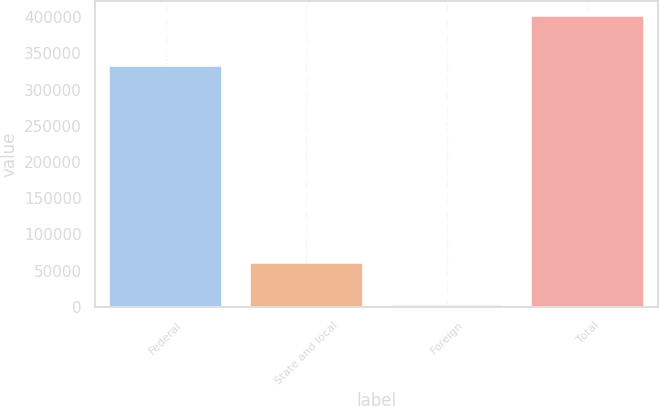Convert chart to OTSL. <chart><loc_0><loc_0><loc_500><loc_500><bar_chart><fcel>Federal<fcel>State and local<fcel>Foreign<fcel>Total<nl><fcel>332053<fcel>60708<fcel>2649<fcel>401897<nl></chart> 